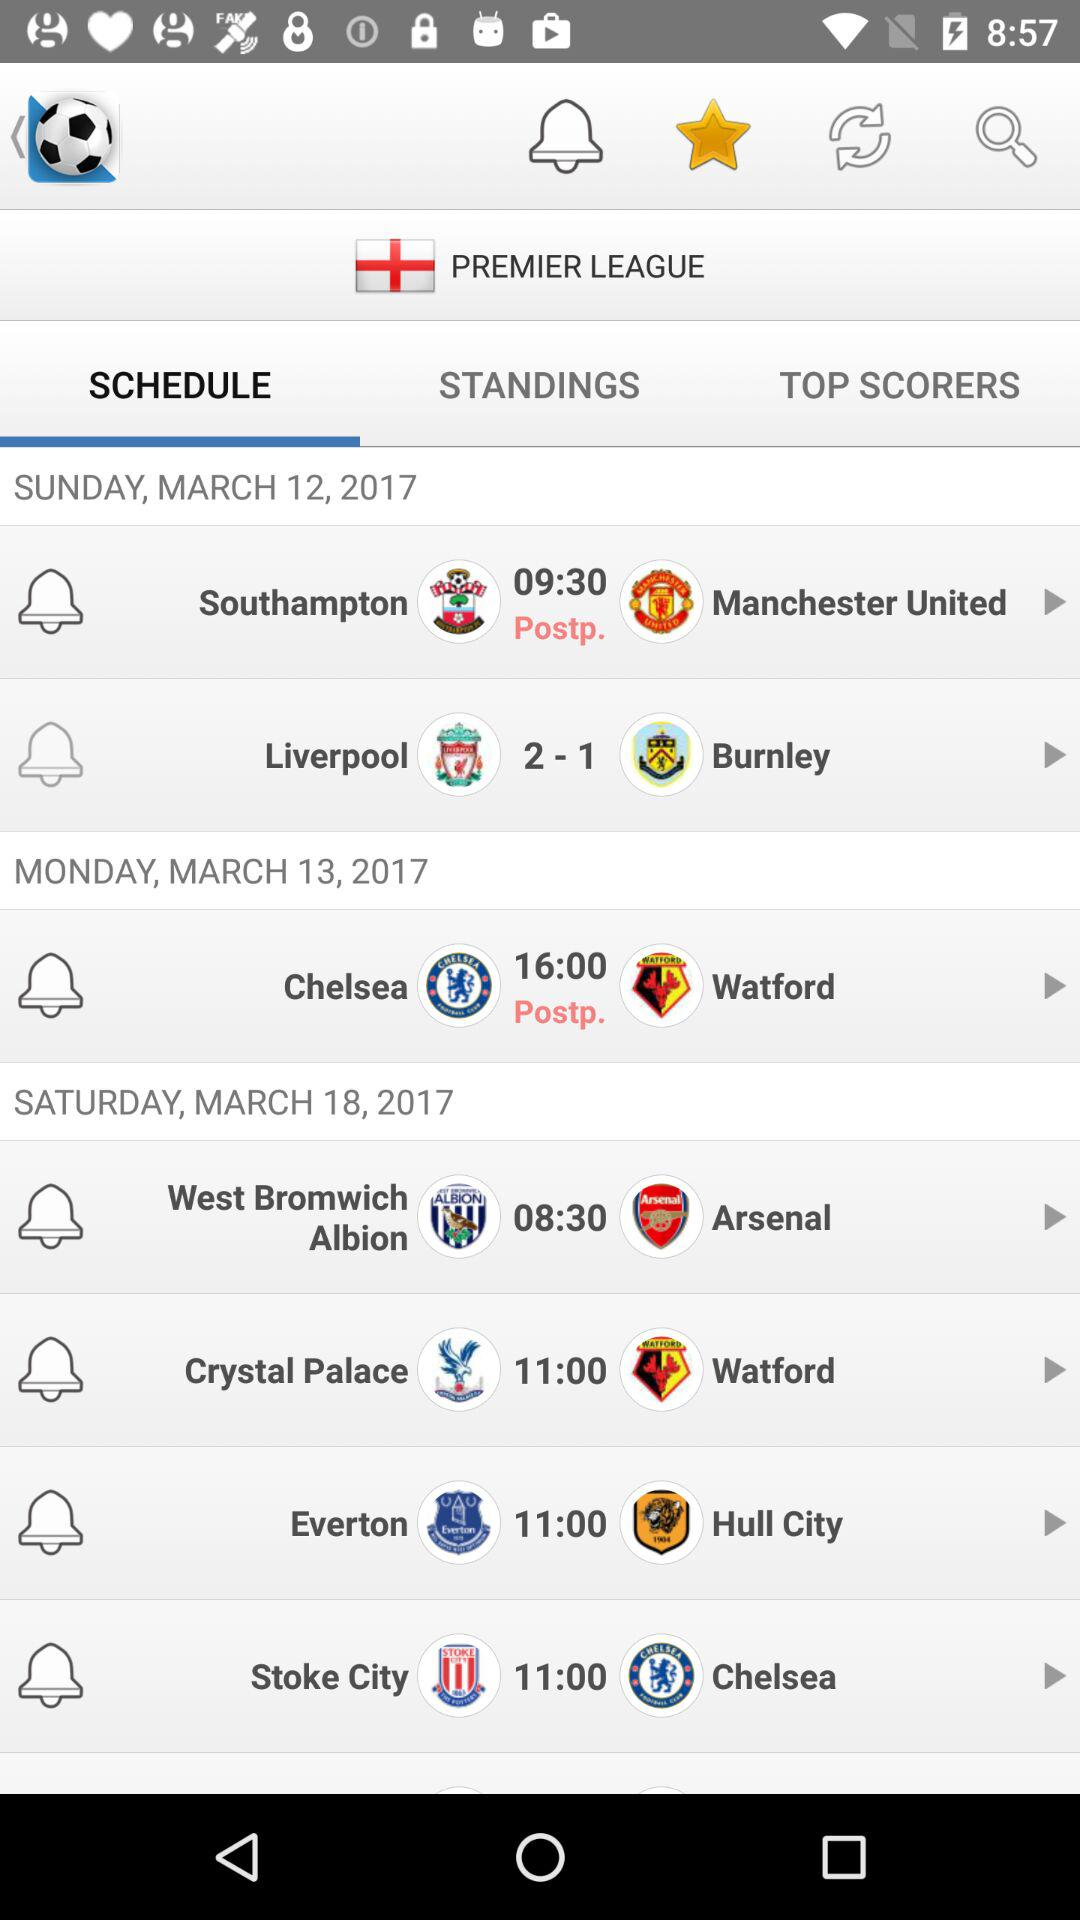Which tab is selected? The selected tab is "SCHEDULE". 